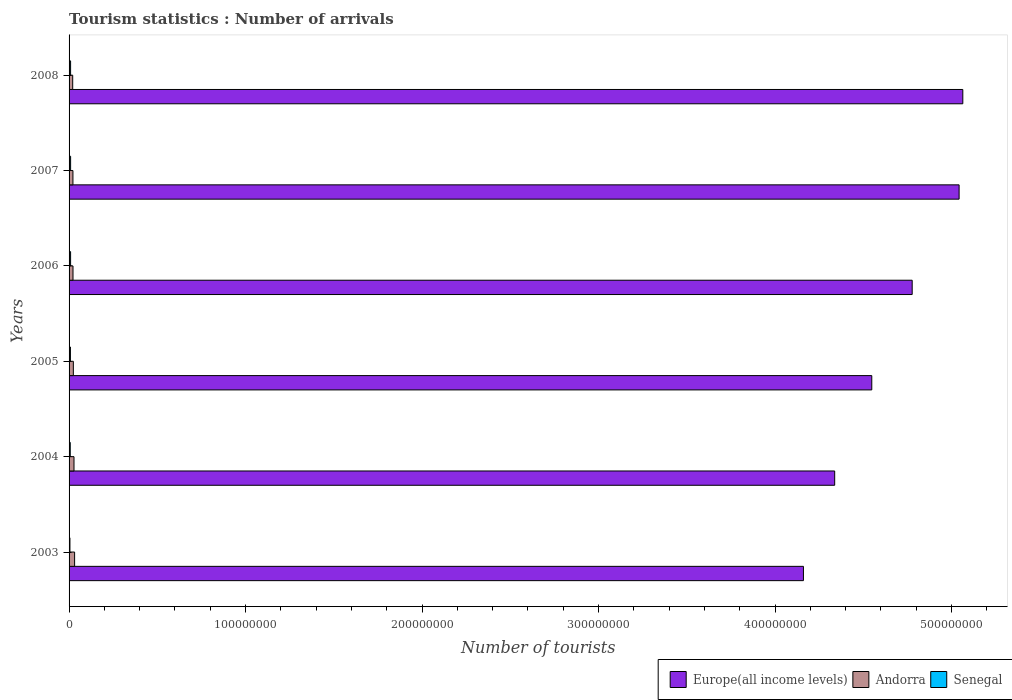Are the number of bars on each tick of the Y-axis equal?
Offer a terse response. Yes. How many bars are there on the 5th tick from the top?
Keep it short and to the point. 3. How many bars are there on the 3rd tick from the bottom?
Offer a very short reply. 3. In how many cases, is the number of bars for a given year not equal to the number of legend labels?
Your answer should be very brief. 0. What is the number of tourist arrivals in Senegal in 2006?
Your answer should be very brief. 8.66e+05. Across all years, what is the maximum number of tourist arrivals in Senegal?
Offer a terse response. 8.75e+05. Across all years, what is the minimum number of tourist arrivals in Senegal?
Offer a terse response. 4.95e+05. In which year was the number of tourist arrivals in Andorra maximum?
Make the answer very short. 2003. In which year was the number of tourist arrivals in Senegal minimum?
Keep it short and to the point. 2003. What is the total number of tourist arrivals in Senegal in the graph?
Your answer should be very brief. 4.54e+06. What is the difference between the number of tourist arrivals in Andorra in 2004 and that in 2005?
Provide a succinct answer. 3.73e+05. What is the difference between the number of tourist arrivals in Senegal in 2005 and the number of tourist arrivals in Andorra in 2007?
Keep it short and to the point. -1.42e+06. What is the average number of tourist arrivals in Senegal per year?
Your answer should be compact. 7.56e+05. In the year 2007, what is the difference between the number of tourist arrivals in Europe(all income levels) and number of tourist arrivals in Andorra?
Make the answer very short. 5.02e+08. What is the ratio of the number of tourist arrivals in Senegal in 2007 to that in 2008?
Your answer should be compact. 1.01. Is the number of tourist arrivals in Senegal in 2004 less than that in 2005?
Keep it short and to the point. Yes. What is the difference between the highest and the second highest number of tourist arrivals in Andorra?
Give a very brief answer. 3.47e+05. What is the difference between the highest and the lowest number of tourist arrivals in Andorra?
Ensure brevity in your answer.  1.08e+06. In how many years, is the number of tourist arrivals in Andorra greater than the average number of tourist arrivals in Andorra taken over all years?
Your answer should be very brief. 2. Is the sum of the number of tourist arrivals in Andorra in 2003 and 2007 greater than the maximum number of tourist arrivals in Senegal across all years?
Ensure brevity in your answer.  Yes. What does the 2nd bar from the top in 2008 represents?
Provide a short and direct response. Andorra. What does the 1st bar from the bottom in 2005 represents?
Your response must be concise. Europe(all income levels). How many bars are there?
Your answer should be compact. 18. Are all the bars in the graph horizontal?
Your answer should be compact. Yes. What is the difference between two consecutive major ticks on the X-axis?
Your answer should be very brief. 1.00e+08. Are the values on the major ticks of X-axis written in scientific E-notation?
Keep it short and to the point. No. Does the graph contain grids?
Offer a terse response. No. Where does the legend appear in the graph?
Ensure brevity in your answer.  Bottom right. How many legend labels are there?
Your answer should be very brief. 3. How are the legend labels stacked?
Your response must be concise. Horizontal. What is the title of the graph?
Provide a succinct answer. Tourism statistics : Number of arrivals. Does "Malawi" appear as one of the legend labels in the graph?
Your answer should be compact. No. What is the label or title of the X-axis?
Give a very brief answer. Number of tourists. What is the Number of tourists of Europe(all income levels) in 2003?
Your response must be concise. 4.16e+08. What is the Number of tourists of Andorra in 2003?
Provide a succinct answer. 3.14e+06. What is the Number of tourists of Senegal in 2003?
Provide a succinct answer. 4.95e+05. What is the Number of tourists of Europe(all income levels) in 2004?
Your answer should be very brief. 4.34e+08. What is the Number of tourists in Andorra in 2004?
Provide a succinct answer. 2.79e+06. What is the Number of tourists in Senegal in 2004?
Your answer should be compact. 6.67e+05. What is the Number of tourists in Europe(all income levels) in 2005?
Offer a very short reply. 4.55e+08. What is the Number of tourists of Andorra in 2005?
Your answer should be compact. 2.42e+06. What is the Number of tourists in Senegal in 2005?
Make the answer very short. 7.69e+05. What is the Number of tourists in Europe(all income levels) in 2006?
Offer a terse response. 4.78e+08. What is the Number of tourists of Andorra in 2006?
Your response must be concise. 2.23e+06. What is the Number of tourists in Senegal in 2006?
Give a very brief answer. 8.66e+05. What is the Number of tourists of Europe(all income levels) in 2007?
Provide a short and direct response. 5.04e+08. What is the Number of tourists of Andorra in 2007?
Make the answer very short. 2.19e+06. What is the Number of tourists of Senegal in 2007?
Give a very brief answer. 8.75e+05. What is the Number of tourists in Europe(all income levels) in 2008?
Keep it short and to the point. 5.06e+08. What is the Number of tourists in Andorra in 2008?
Provide a short and direct response. 2.06e+06. What is the Number of tourists in Senegal in 2008?
Provide a short and direct response. 8.67e+05. Across all years, what is the maximum Number of tourists in Europe(all income levels)?
Your answer should be very brief. 5.06e+08. Across all years, what is the maximum Number of tourists in Andorra?
Offer a terse response. 3.14e+06. Across all years, what is the maximum Number of tourists of Senegal?
Provide a succinct answer. 8.75e+05. Across all years, what is the minimum Number of tourists of Europe(all income levels)?
Your answer should be compact. 4.16e+08. Across all years, what is the minimum Number of tourists in Andorra?
Your answer should be very brief. 2.06e+06. Across all years, what is the minimum Number of tourists in Senegal?
Your answer should be very brief. 4.95e+05. What is the total Number of tourists of Europe(all income levels) in the graph?
Make the answer very short. 2.79e+09. What is the total Number of tourists of Andorra in the graph?
Your response must be concise. 1.48e+07. What is the total Number of tourists in Senegal in the graph?
Ensure brevity in your answer.  4.54e+06. What is the difference between the Number of tourists of Europe(all income levels) in 2003 and that in 2004?
Your answer should be compact. -1.77e+07. What is the difference between the Number of tourists in Andorra in 2003 and that in 2004?
Ensure brevity in your answer.  3.47e+05. What is the difference between the Number of tourists of Senegal in 2003 and that in 2004?
Your answer should be very brief. -1.72e+05. What is the difference between the Number of tourists of Europe(all income levels) in 2003 and that in 2005?
Offer a very short reply. -3.87e+07. What is the difference between the Number of tourists in Andorra in 2003 and that in 2005?
Your answer should be very brief. 7.20e+05. What is the difference between the Number of tourists of Senegal in 2003 and that in 2005?
Ensure brevity in your answer.  -2.74e+05. What is the difference between the Number of tourists in Europe(all income levels) in 2003 and that in 2006?
Offer a very short reply. -6.16e+07. What is the difference between the Number of tourists in Andorra in 2003 and that in 2006?
Make the answer very short. 9.11e+05. What is the difference between the Number of tourists in Senegal in 2003 and that in 2006?
Offer a terse response. -3.71e+05. What is the difference between the Number of tourists in Europe(all income levels) in 2003 and that in 2007?
Make the answer very short. -8.82e+07. What is the difference between the Number of tourists of Andorra in 2003 and that in 2007?
Keep it short and to the point. 9.49e+05. What is the difference between the Number of tourists in Senegal in 2003 and that in 2007?
Keep it short and to the point. -3.80e+05. What is the difference between the Number of tourists in Europe(all income levels) in 2003 and that in 2008?
Keep it short and to the point. -9.03e+07. What is the difference between the Number of tourists of Andorra in 2003 and that in 2008?
Ensure brevity in your answer.  1.08e+06. What is the difference between the Number of tourists of Senegal in 2003 and that in 2008?
Your response must be concise. -3.72e+05. What is the difference between the Number of tourists of Europe(all income levels) in 2004 and that in 2005?
Provide a succinct answer. -2.10e+07. What is the difference between the Number of tourists of Andorra in 2004 and that in 2005?
Provide a short and direct response. 3.73e+05. What is the difference between the Number of tourists in Senegal in 2004 and that in 2005?
Offer a very short reply. -1.02e+05. What is the difference between the Number of tourists in Europe(all income levels) in 2004 and that in 2006?
Keep it short and to the point. -4.39e+07. What is the difference between the Number of tourists in Andorra in 2004 and that in 2006?
Offer a terse response. 5.64e+05. What is the difference between the Number of tourists of Senegal in 2004 and that in 2006?
Your answer should be compact. -1.99e+05. What is the difference between the Number of tourists of Europe(all income levels) in 2004 and that in 2007?
Provide a short and direct response. -7.05e+07. What is the difference between the Number of tourists of Andorra in 2004 and that in 2007?
Your response must be concise. 6.02e+05. What is the difference between the Number of tourists of Senegal in 2004 and that in 2007?
Ensure brevity in your answer.  -2.08e+05. What is the difference between the Number of tourists of Europe(all income levels) in 2004 and that in 2008?
Offer a terse response. -7.26e+07. What is the difference between the Number of tourists of Andorra in 2004 and that in 2008?
Keep it short and to the point. 7.32e+05. What is the difference between the Number of tourists in Senegal in 2004 and that in 2008?
Your answer should be compact. -2.00e+05. What is the difference between the Number of tourists of Europe(all income levels) in 2005 and that in 2006?
Offer a terse response. -2.29e+07. What is the difference between the Number of tourists in Andorra in 2005 and that in 2006?
Provide a succinct answer. 1.91e+05. What is the difference between the Number of tourists in Senegal in 2005 and that in 2006?
Provide a succinct answer. -9.70e+04. What is the difference between the Number of tourists of Europe(all income levels) in 2005 and that in 2007?
Provide a short and direct response. -4.95e+07. What is the difference between the Number of tourists in Andorra in 2005 and that in 2007?
Your response must be concise. 2.29e+05. What is the difference between the Number of tourists in Senegal in 2005 and that in 2007?
Make the answer very short. -1.06e+05. What is the difference between the Number of tourists of Europe(all income levels) in 2005 and that in 2008?
Provide a short and direct response. -5.16e+07. What is the difference between the Number of tourists of Andorra in 2005 and that in 2008?
Offer a very short reply. 3.59e+05. What is the difference between the Number of tourists of Senegal in 2005 and that in 2008?
Your response must be concise. -9.80e+04. What is the difference between the Number of tourists in Europe(all income levels) in 2006 and that in 2007?
Your answer should be compact. -2.66e+07. What is the difference between the Number of tourists of Andorra in 2006 and that in 2007?
Provide a short and direct response. 3.80e+04. What is the difference between the Number of tourists of Senegal in 2006 and that in 2007?
Make the answer very short. -9000. What is the difference between the Number of tourists in Europe(all income levels) in 2006 and that in 2008?
Keep it short and to the point. -2.87e+07. What is the difference between the Number of tourists in Andorra in 2006 and that in 2008?
Make the answer very short. 1.68e+05. What is the difference between the Number of tourists in Senegal in 2006 and that in 2008?
Keep it short and to the point. -1000. What is the difference between the Number of tourists in Europe(all income levels) in 2007 and that in 2008?
Offer a very short reply. -2.09e+06. What is the difference between the Number of tourists of Andorra in 2007 and that in 2008?
Make the answer very short. 1.30e+05. What is the difference between the Number of tourists of Senegal in 2007 and that in 2008?
Provide a short and direct response. 8000. What is the difference between the Number of tourists in Europe(all income levels) in 2003 and the Number of tourists in Andorra in 2004?
Your answer should be compact. 4.13e+08. What is the difference between the Number of tourists of Europe(all income levels) in 2003 and the Number of tourists of Senegal in 2004?
Make the answer very short. 4.15e+08. What is the difference between the Number of tourists of Andorra in 2003 and the Number of tourists of Senegal in 2004?
Your answer should be compact. 2.47e+06. What is the difference between the Number of tourists of Europe(all income levels) in 2003 and the Number of tourists of Andorra in 2005?
Offer a very short reply. 4.14e+08. What is the difference between the Number of tourists in Europe(all income levels) in 2003 and the Number of tourists in Senegal in 2005?
Ensure brevity in your answer.  4.15e+08. What is the difference between the Number of tourists in Andorra in 2003 and the Number of tourists in Senegal in 2005?
Keep it short and to the point. 2.37e+06. What is the difference between the Number of tourists in Europe(all income levels) in 2003 and the Number of tourists in Andorra in 2006?
Make the answer very short. 4.14e+08. What is the difference between the Number of tourists of Europe(all income levels) in 2003 and the Number of tourists of Senegal in 2006?
Give a very brief answer. 4.15e+08. What is the difference between the Number of tourists of Andorra in 2003 and the Number of tourists of Senegal in 2006?
Offer a terse response. 2.27e+06. What is the difference between the Number of tourists of Europe(all income levels) in 2003 and the Number of tourists of Andorra in 2007?
Your answer should be very brief. 4.14e+08. What is the difference between the Number of tourists in Europe(all income levels) in 2003 and the Number of tourists in Senegal in 2007?
Your response must be concise. 4.15e+08. What is the difference between the Number of tourists in Andorra in 2003 and the Number of tourists in Senegal in 2007?
Provide a succinct answer. 2.26e+06. What is the difference between the Number of tourists in Europe(all income levels) in 2003 and the Number of tourists in Andorra in 2008?
Your answer should be compact. 4.14e+08. What is the difference between the Number of tourists in Europe(all income levels) in 2003 and the Number of tourists in Senegal in 2008?
Your answer should be very brief. 4.15e+08. What is the difference between the Number of tourists of Andorra in 2003 and the Number of tourists of Senegal in 2008?
Provide a succinct answer. 2.27e+06. What is the difference between the Number of tourists in Europe(all income levels) in 2004 and the Number of tourists in Andorra in 2005?
Make the answer very short. 4.31e+08. What is the difference between the Number of tourists of Europe(all income levels) in 2004 and the Number of tourists of Senegal in 2005?
Keep it short and to the point. 4.33e+08. What is the difference between the Number of tourists of Andorra in 2004 and the Number of tourists of Senegal in 2005?
Your answer should be compact. 2.02e+06. What is the difference between the Number of tourists of Europe(all income levels) in 2004 and the Number of tourists of Andorra in 2006?
Keep it short and to the point. 4.32e+08. What is the difference between the Number of tourists of Europe(all income levels) in 2004 and the Number of tourists of Senegal in 2006?
Ensure brevity in your answer.  4.33e+08. What is the difference between the Number of tourists of Andorra in 2004 and the Number of tourists of Senegal in 2006?
Your response must be concise. 1.92e+06. What is the difference between the Number of tourists of Europe(all income levels) in 2004 and the Number of tourists of Andorra in 2007?
Provide a succinct answer. 4.32e+08. What is the difference between the Number of tourists in Europe(all income levels) in 2004 and the Number of tourists in Senegal in 2007?
Your response must be concise. 4.33e+08. What is the difference between the Number of tourists in Andorra in 2004 and the Number of tourists in Senegal in 2007?
Provide a succinct answer. 1.92e+06. What is the difference between the Number of tourists of Europe(all income levels) in 2004 and the Number of tourists of Andorra in 2008?
Give a very brief answer. 4.32e+08. What is the difference between the Number of tourists in Europe(all income levels) in 2004 and the Number of tourists in Senegal in 2008?
Ensure brevity in your answer.  4.33e+08. What is the difference between the Number of tourists of Andorra in 2004 and the Number of tourists of Senegal in 2008?
Ensure brevity in your answer.  1.92e+06. What is the difference between the Number of tourists in Europe(all income levels) in 2005 and the Number of tourists in Andorra in 2006?
Your answer should be compact. 4.53e+08. What is the difference between the Number of tourists in Europe(all income levels) in 2005 and the Number of tourists in Senegal in 2006?
Offer a terse response. 4.54e+08. What is the difference between the Number of tourists of Andorra in 2005 and the Number of tourists of Senegal in 2006?
Your answer should be compact. 1.55e+06. What is the difference between the Number of tourists of Europe(all income levels) in 2005 and the Number of tourists of Andorra in 2007?
Ensure brevity in your answer.  4.53e+08. What is the difference between the Number of tourists in Europe(all income levels) in 2005 and the Number of tourists in Senegal in 2007?
Offer a terse response. 4.54e+08. What is the difference between the Number of tourists of Andorra in 2005 and the Number of tourists of Senegal in 2007?
Offer a very short reply. 1.54e+06. What is the difference between the Number of tourists of Europe(all income levels) in 2005 and the Number of tourists of Andorra in 2008?
Provide a succinct answer. 4.53e+08. What is the difference between the Number of tourists of Europe(all income levels) in 2005 and the Number of tourists of Senegal in 2008?
Ensure brevity in your answer.  4.54e+08. What is the difference between the Number of tourists of Andorra in 2005 and the Number of tourists of Senegal in 2008?
Your response must be concise. 1.55e+06. What is the difference between the Number of tourists of Europe(all income levels) in 2006 and the Number of tourists of Andorra in 2007?
Your response must be concise. 4.76e+08. What is the difference between the Number of tourists of Europe(all income levels) in 2006 and the Number of tourists of Senegal in 2007?
Make the answer very short. 4.77e+08. What is the difference between the Number of tourists of Andorra in 2006 and the Number of tourists of Senegal in 2007?
Provide a succinct answer. 1.35e+06. What is the difference between the Number of tourists in Europe(all income levels) in 2006 and the Number of tourists in Andorra in 2008?
Your answer should be compact. 4.76e+08. What is the difference between the Number of tourists of Europe(all income levels) in 2006 and the Number of tourists of Senegal in 2008?
Offer a very short reply. 4.77e+08. What is the difference between the Number of tourists in Andorra in 2006 and the Number of tourists in Senegal in 2008?
Your answer should be very brief. 1.36e+06. What is the difference between the Number of tourists in Europe(all income levels) in 2007 and the Number of tourists in Andorra in 2008?
Keep it short and to the point. 5.02e+08. What is the difference between the Number of tourists of Europe(all income levels) in 2007 and the Number of tourists of Senegal in 2008?
Provide a short and direct response. 5.03e+08. What is the difference between the Number of tourists in Andorra in 2007 and the Number of tourists in Senegal in 2008?
Offer a very short reply. 1.32e+06. What is the average Number of tourists in Europe(all income levels) per year?
Your answer should be compact. 4.66e+08. What is the average Number of tourists of Andorra per year?
Make the answer very short. 2.47e+06. What is the average Number of tourists of Senegal per year?
Your answer should be compact. 7.56e+05. In the year 2003, what is the difference between the Number of tourists in Europe(all income levels) and Number of tourists in Andorra?
Offer a very short reply. 4.13e+08. In the year 2003, what is the difference between the Number of tourists in Europe(all income levels) and Number of tourists in Senegal?
Keep it short and to the point. 4.16e+08. In the year 2003, what is the difference between the Number of tourists in Andorra and Number of tourists in Senegal?
Your answer should be very brief. 2.64e+06. In the year 2004, what is the difference between the Number of tourists in Europe(all income levels) and Number of tourists in Andorra?
Offer a terse response. 4.31e+08. In the year 2004, what is the difference between the Number of tourists of Europe(all income levels) and Number of tourists of Senegal?
Your answer should be compact. 4.33e+08. In the year 2004, what is the difference between the Number of tourists in Andorra and Number of tourists in Senegal?
Give a very brief answer. 2.12e+06. In the year 2005, what is the difference between the Number of tourists of Europe(all income levels) and Number of tourists of Andorra?
Provide a succinct answer. 4.52e+08. In the year 2005, what is the difference between the Number of tourists of Europe(all income levels) and Number of tourists of Senegal?
Your answer should be very brief. 4.54e+08. In the year 2005, what is the difference between the Number of tourists of Andorra and Number of tourists of Senegal?
Keep it short and to the point. 1.65e+06. In the year 2006, what is the difference between the Number of tourists in Europe(all income levels) and Number of tourists in Andorra?
Make the answer very short. 4.75e+08. In the year 2006, what is the difference between the Number of tourists of Europe(all income levels) and Number of tourists of Senegal?
Offer a very short reply. 4.77e+08. In the year 2006, what is the difference between the Number of tourists of Andorra and Number of tourists of Senegal?
Keep it short and to the point. 1.36e+06. In the year 2007, what is the difference between the Number of tourists of Europe(all income levels) and Number of tourists of Andorra?
Keep it short and to the point. 5.02e+08. In the year 2007, what is the difference between the Number of tourists of Europe(all income levels) and Number of tourists of Senegal?
Provide a succinct answer. 5.03e+08. In the year 2007, what is the difference between the Number of tourists of Andorra and Number of tourists of Senegal?
Your answer should be very brief. 1.31e+06. In the year 2008, what is the difference between the Number of tourists of Europe(all income levels) and Number of tourists of Andorra?
Make the answer very short. 5.04e+08. In the year 2008, what is the difference between the Number of tourists of Europe(all income levels) and Number of tourists of Senegal?
Provide a short and direct response. 5.06e+08. In the year 2008, what is the difference between the Number of tourists in Andorra and Number of tourists in Senegal?
Offer a very short reply. 1.19e+06. What is the ratio of the Number of tourists of Europe(all income levels) in 2003 to that in 2004?
Offer a terse response. 0.96. What is the ratio of the Number of tourists in Andorra in 2003 to that in 2004?
Your answer should be very brief. 1.12. What is the ratio of the Number of tourists of Senegal in 2003 to that in 2004?
Your response must be concise. 0.74. What is the ratio of the Number of tourists of Europe(all income levels) in 2003 to that in 2005?
Your answer should be very brief. 0.91. What is the ratio of the Number of tourists in Andorra in 2003 to that in 2005?
Keep it short and to the point. 1.3. What is the ratio of the Number of tourists of Senegal in 2003 to that in 2005?
Make the answer very short. 0.64. What is the ratio of the Number of tourists in Europe(all income levels) in 2003 to that in 2006?
Your response must be concise. 0.87. What is the ratio of the Number of tourists in Andorra in 2003 to that in 2006?
Give a very brief answer. 1.41. What is the ratio of the Number of tourists of Senegal in 2003 to that in 2006?
Your answer should be very brief. 0.57. What is the ratio of the Number of tourists of Europe(all income levels) in 2003 to that in 2007?
Offer a terse response. 0.83. What is the ratio of the Number of tourists of Andorra in 2003 to that in 2007?
Make the answer very short. 1.43. What is the ratio of the Number of tourists of Senegal in 2003 to that in 2007?
Offer a terse response. 0.57. What is the ratio of the Number of tourists in Europe(all income levels) in 2003 to that in 2008?
Offer a very short reply. 0.82. What is the ratio of the Number of tourists in Andorra in 2003 to that in 2008?
Ensure brevity in your answer.  1.52. What is the ratio of the Number of tourists in Senegal in 2003 to that in 2008?
Keep it short and to the point. 0.57. What is the ratio of the Number of tourists in Europe(all income levels) in 2004 to that in 2005?
Offer a terse response. 0.95. What is the ratio of the Number of tourists of Andorra in 2004 to that in 2005?
Provide a short and direct response. 1.15. What is the ratio of the Number of tourists of Senegal in 2004 to that in 2005?
Your response must be concise. 0.87. What is the ratio of the Number of tourists in Europe(all income levels) in 2004 to that in 2006?
Your answer should be compact. 0.91. What is the ratio of the Number of tourists in Andorra in 2004 to that in 2006?
Provide a succinct answer. 1.25. What is the ratio of the Number of tourists in Senegal in 2004 to that in 2006?
Provide a short and direct response. 0.77. What is the ratio of the Number of tourists in Europe(all income levels) in 2004 to that in 2007?
Your response must be concise. 0.86. What is the ratio of the Number of tourists of Andorra in 2004 to that in 2007?
Your response must be concise. 1.27. What is the ratio of the Number of tourists in Senegal in 2004 to that in 2007?
Your answer should be very brief. 0.76. What is the ratio of the Number of tourists in Europe(all income levels) in 2004 to that in 2008?
Your answer should be compact. 0.86. What is the ratio of the Number of tourists of Andorra in 2004 to that in 2008?
Keep it short and to the point. 1.36. What is the ratio of the Number of tourists in Senegal in 2004 to that in 2008?
Provide a short and direct response. 0.77. What is the ratio of the Number of tourists in Europe(all income levels) in 2005 to that in 2006?
Keep it short and to the point. 0.95. What is the ratio of the Number of tourists in Andorra in 2005 to that in 2006?
Provide a short and direct response. 1.09. What is the ratio of the Number of tourists of Senegal in 2005 to that in 2006?
Your answer should be compact. 0.89. What is the ratio of the Number of tourists of Europe(all income levels) in 2005 to that in 2007?
Your response must be concise. 0.9. What is the ratio of the Number of tourists in Andorra in 2005 to that in 2007?
Offer a terse response. 1.1. What is the ratio of the Number of tourists in Senegal in 2005 to that in 2007?
Your response must be concise. 0.88. What is the ratio of the Number of tourists of Europe(all income levels) in 2005 to that in 2008?
Your response must be concise. 0.9. What is the ratio of the Number of tourists of Andorra in 2005 to that in 2008?
Give a very brief answer. 1.17. What is the ratio of the Number of tourists of Senegal in 2005 to that in 2008?
Make the answer very short. 0.89. What is the ratio of the Number of tourists of Europe(all income levels) in 2006 to that in 2007?
Provide a succinct answer. 0.95. What is the ratio of the Number of tourists in Andorra in 2006 to that in 2007?
Ensure brevity in your answer.  1.02. What is the ratio of the Number of tourists in Europe(all income levels) in 2006 to that in 2008?
Offer a very short reply. 0.94. What is the ratio of the Number of tourists of Andorra in 2006 to that in 2008?
Your answer should be very brief. 1.08. What is the ratio of the Number of tourists of Senegal in 2006 to that in 2008?
Keep it short and to the point. 1. What is the ratio of the Number of tourists of Andorra in 2007 to that in 2008?
Keep it short and to the point. 1.06. What is the ratio of the Number of tourists in Senegal in 2007 to that in 2008?
Give a very brief answer. 1.01. What is the difference between the highest and the second highest Number of tourists in Europe(all income levels)?
Offer a terse response. 2.09e+06. What is the difference between the highest and the second highest Number of tourists in Andorra?
Provide a short and direct response. 3.47e+05. What is the difference between the highest and the second highest Number of tourists of Senegal?
Your response must be concise. 8000. What is the difference between the highest and the lowest Number of tourists in Europe(all income levels)?
Make the answer very short. 9.03e+07. What is the difference between the highest and the lowest Number of tourists of Andorra?
Keep it short and to the point. 1.08e+06. 